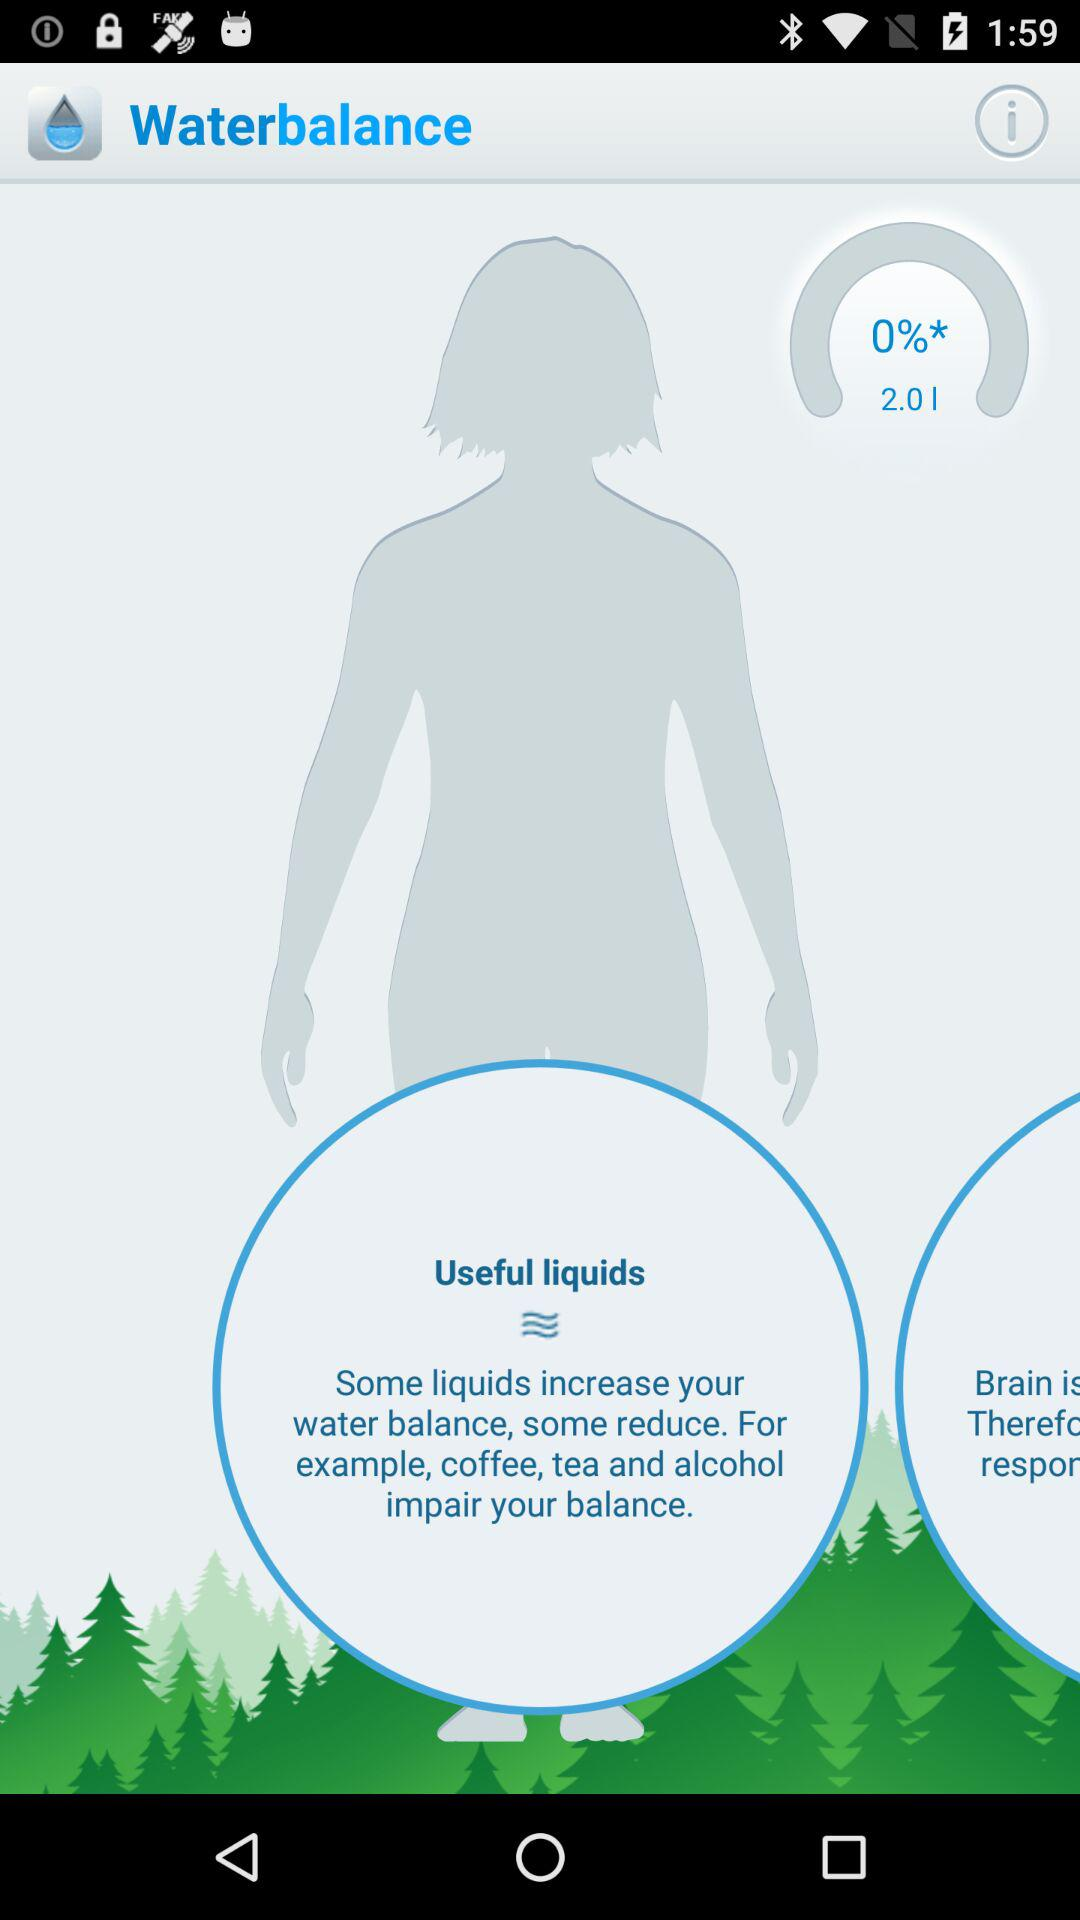What is the application name? The application name is "Waterbalance". 